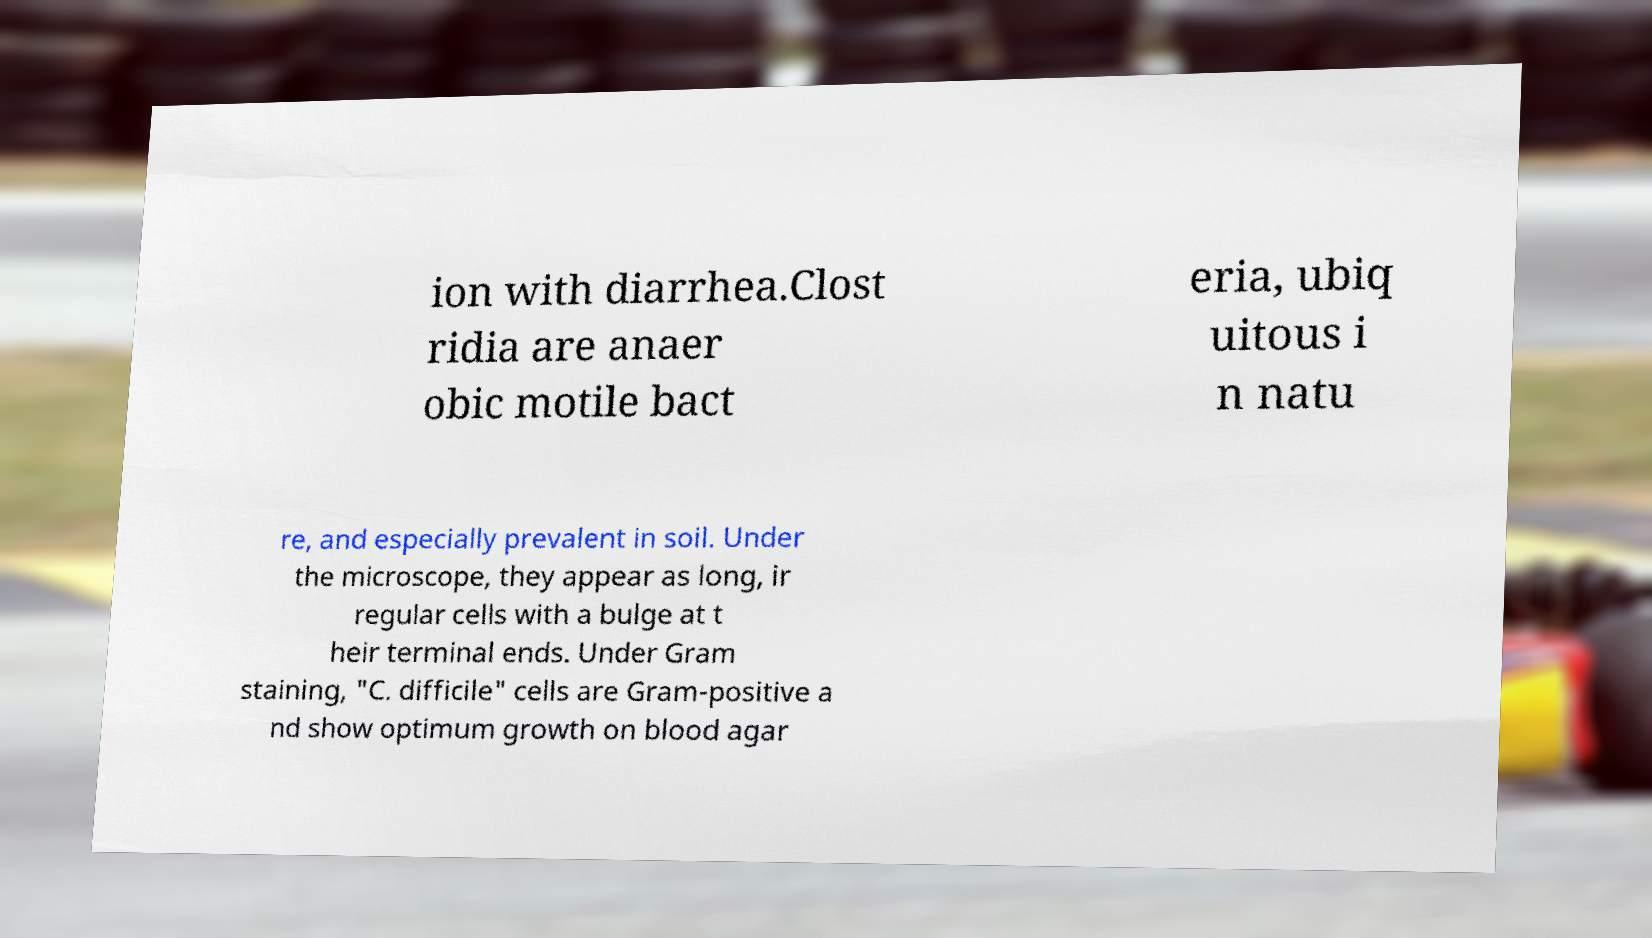Please read and relay the text visible in this image. What does it say? ion with diarrhea.Clost ridia are anaer obic motile bact eria, ubiq uitous i n natu re, and especially prevalent in soil. Under the microscope, they appear as long, ir regular cells with a bulge at t heir terminal ends. Under Gram staining, "C. difficile" cells are Gram-positive a nd show optimum growth on blood agar 